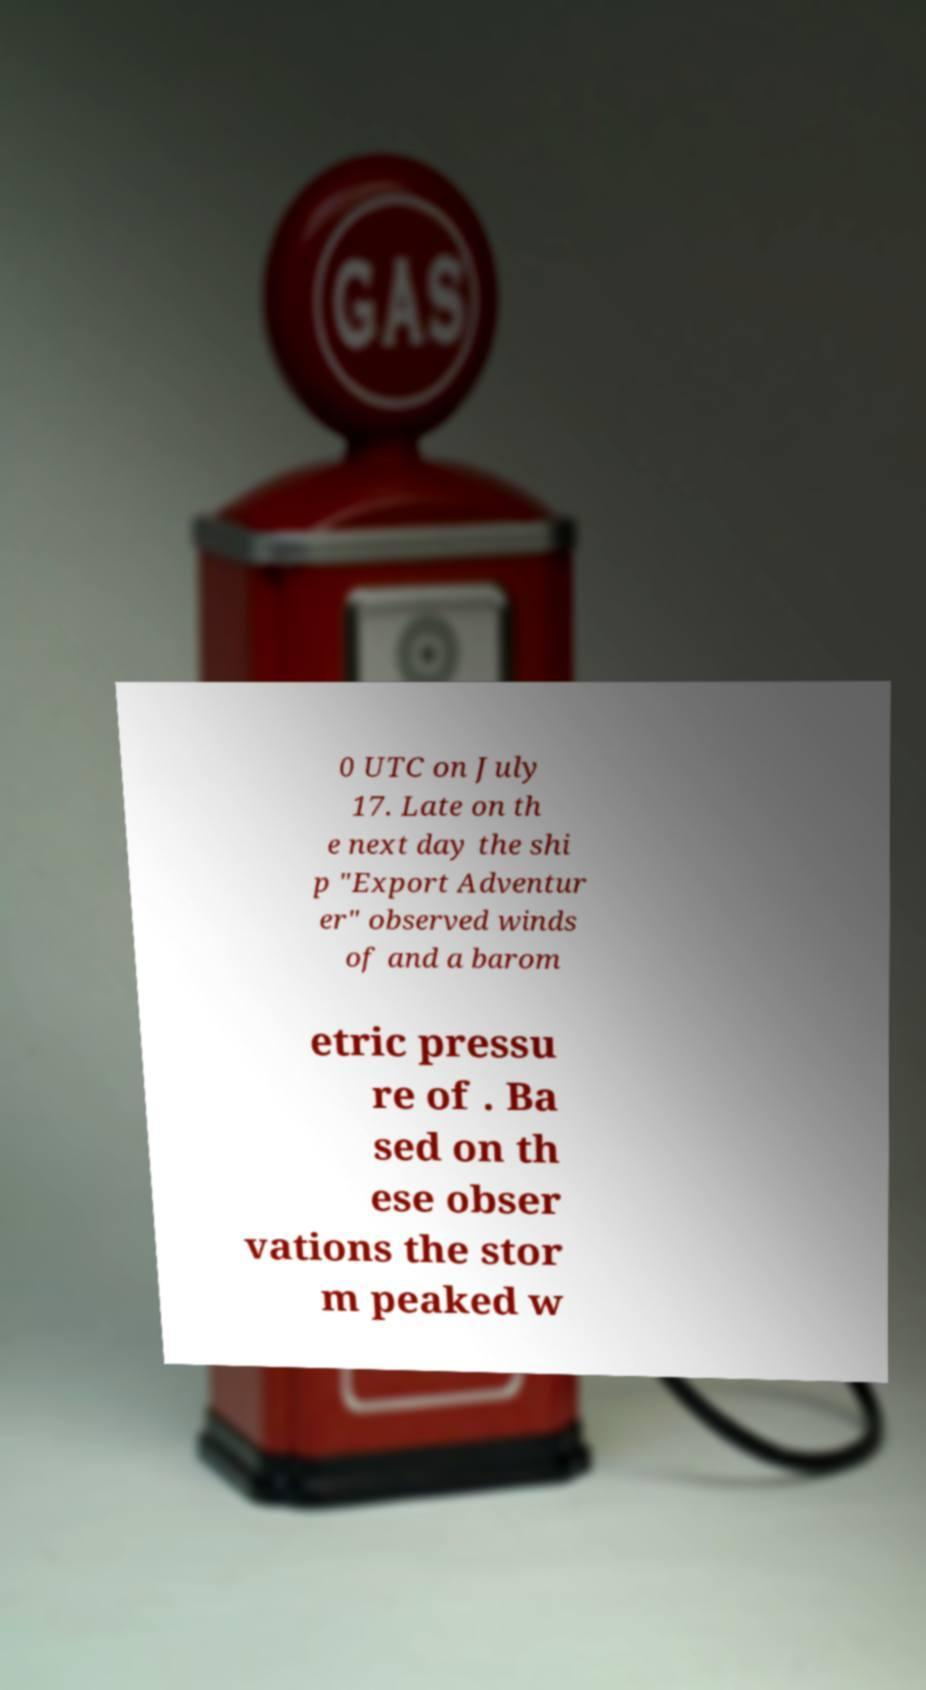What messages or text are displayed in this image? I need them in a readable, typed format. 0 UTC on July 17. Late on th e next day the shi p "Export Adventur er" observed winds of and a barom etric pressu re of . Ba sed on th ese obser vations the stor m peaked w 